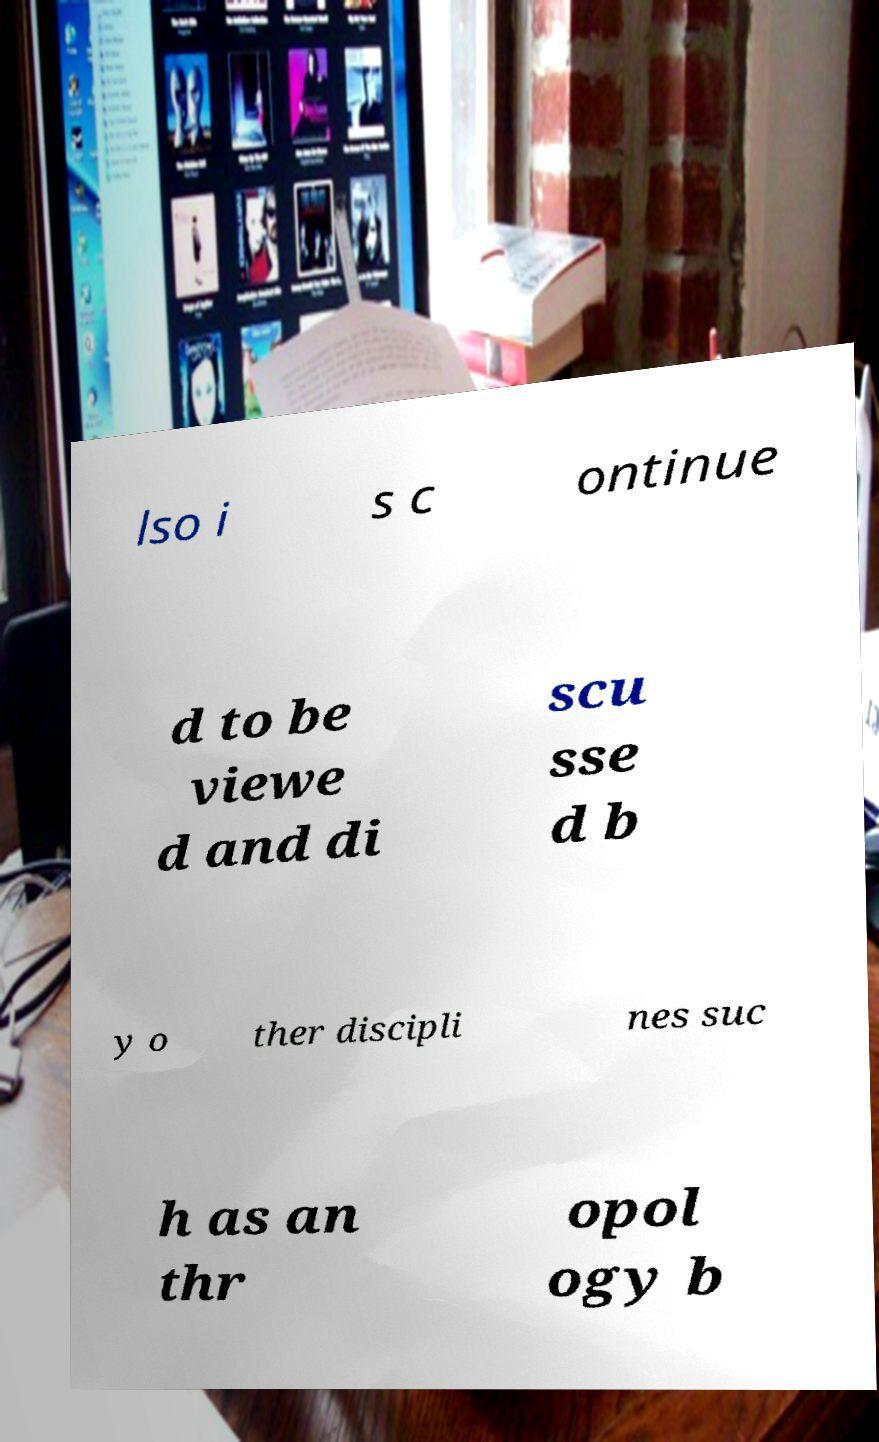Can you accurately transcribe the text from the provided image for me? lso i s c ontinue d to be viewe d and di scu sse d b y o ther discipli nes suc h as an thr opol ogy b 